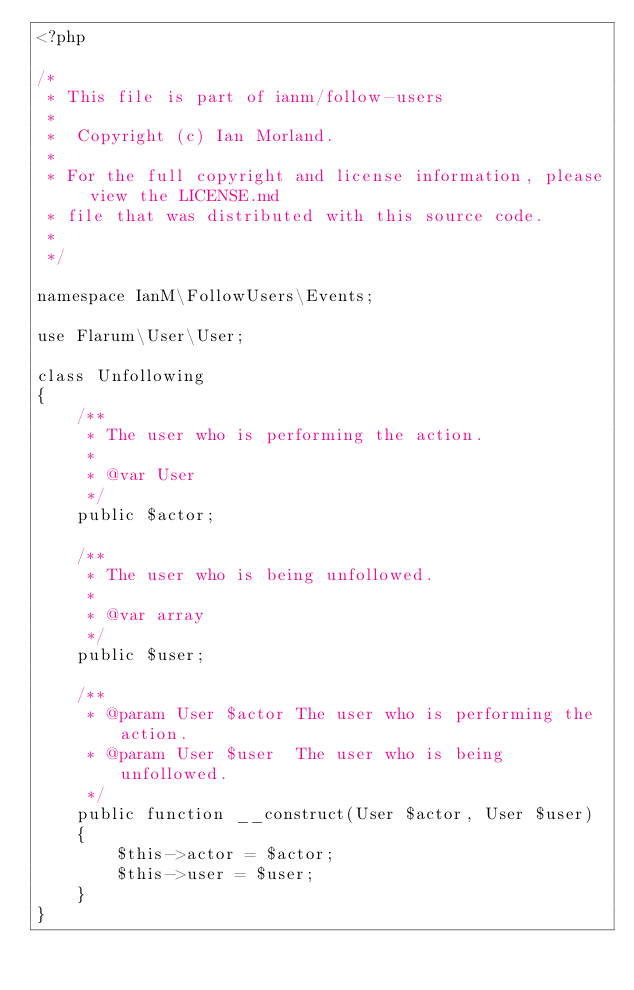<code> <loc_0><loc_0><loc_500><loc_500><_PHP_><?php

/*
 * This file is part of ianm/follow-users
 *
 *  Copyright (c) Ian Morland.
 *
 * For the full copyright and license information, please view the LICENSE.md
 * file that was distributed with this source code.
 *
 */

namespace IanM\FollowUsers\Events;

use Flarum\User\User;

class Unfollowing
{
    /**
     * The user who is performing the action.
     *
     * @var User
     */
    public $actor;

    /**
     * The user who is being unfollowed.
     *
     * @var array
     */
    public $user;

    /**
     * @param User $actor The user who is performing the action.
     * @param User $user  The user who is being unfollowed.
     */
    public function __construct(User $actor, User $user)
    {
        $this->actor = $actor;
        $this->user = $user;
    }
}
</code> 